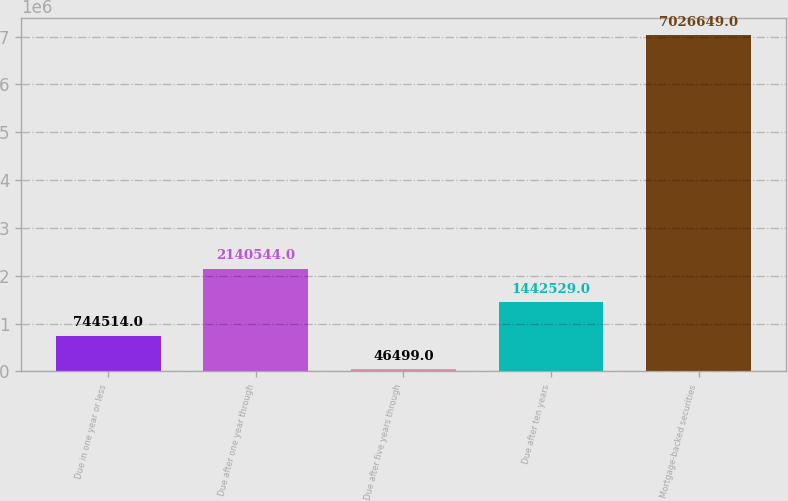Convert chart to OTSL. <chart><loc_0><loc_0><loc_500><loc_500><bar_chart><fcel>Due in one year or less<fcel>Due after one year through<fcel>Due after five years through<fcel>Due after ten years<fcel>Mortgage-backed securities<nl><fcel>744514<fcel>2.14054e+06<fcel>46499<fcel>1.44253e+06<fcel>7.02665e+06<nl></chart> 